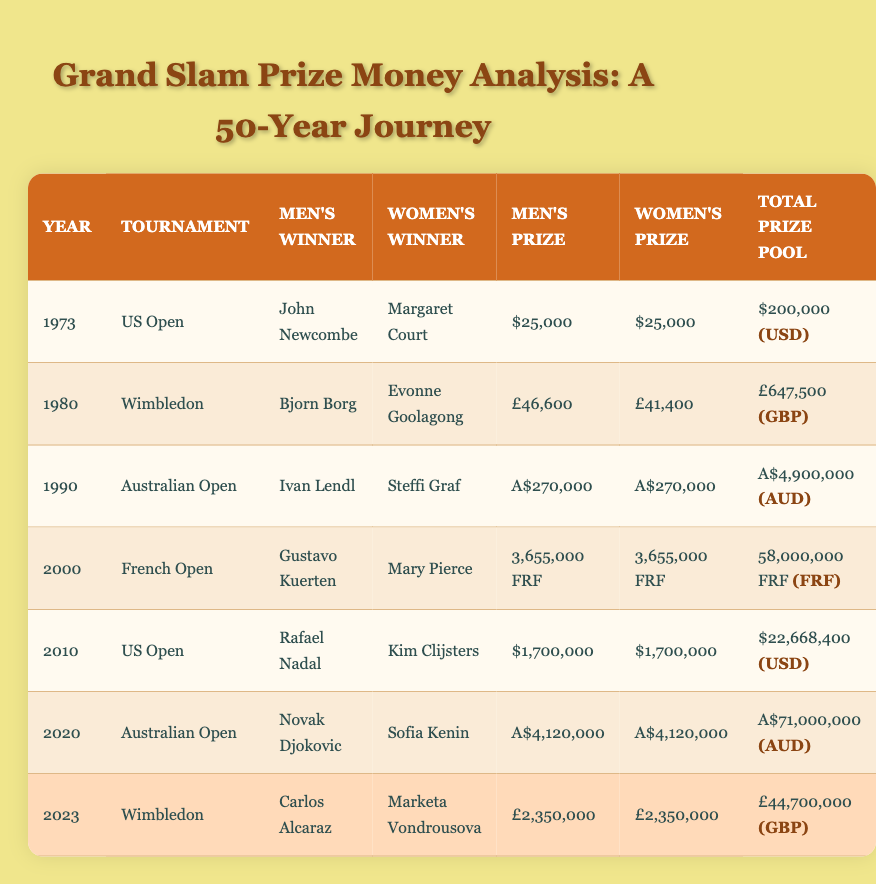What was the total prize pool for the US Open in 2010? The table lists the US Open tournament for the year 2010, where the total prize pool is directly mentioned as $22,668,400.
Answer: $22,668,400 Which men's singles winner received the highest prize money, and how much was it? By reviewing the table, the highest men's prize money is recorded for Novak Djokovic in 2020, which is A$4,120,000.
Answer: A$4,120,000 Was the women’s singles prize in 2023 equal to the men's prize? In the row for 2023, both men's and women's singles winners received £2,350,000, indicating the women's prize is equal to the men's prize.
Answer: Yes What was the average men's prize money across the years 1973, 1980, and 2010? To find the average, sum the men's prizes from those years: $25,000 + £46,600 + $1,700,000. Convert to a common currency (USD): £46,600 ≈ $60,000 (approximately), then total: $25,000 + $60,000 + $1,700,000 = $1,785,000. Divide by 3 for the average: $1,785,000 / 3 = $595,000.
Answer: $595,000 Which tournament had the lowest total prize pool, and what was the amount? By examining the table, the US Open in 1973 has the lowest total prize pool amount of $200,000.
Answer: $200,000 How much more did the total prize pool of the Australian Open in 2020 compare to Wimbledon in 1980? The total prize pool for the Australian Open in 2020 is A$71,000,000, while for Wimbledon in 1980, it is £647,500. First convert £647,500 to AUD (approximate): £1 ≈ A$1.82, thus £647,500 ≈ A$1,179,850. The difference is A$71,000,000 - A$1,179,850 = A$69,820,150.
Answer: A$69,820,150 Did any women's prize exceed £40,000 during the years listed? Checking the table, women's prizes of £41,400 in 1980 and £2,350,000 in 2023 indicate that there were women's prizes exceeding £40,000.
Answer: Yes Which year had the same men's and women's prize money that also exceeded $1,000,000? Analyzing the table, both the Australian Open in 2020 and the US Open in 2010 feature equal men's and women's prizes, both exceeding $1,000,000 (A$4,120,000 and $1,700,000 respectively). The answer is therefore both years.
Answer: 2010, 2020 